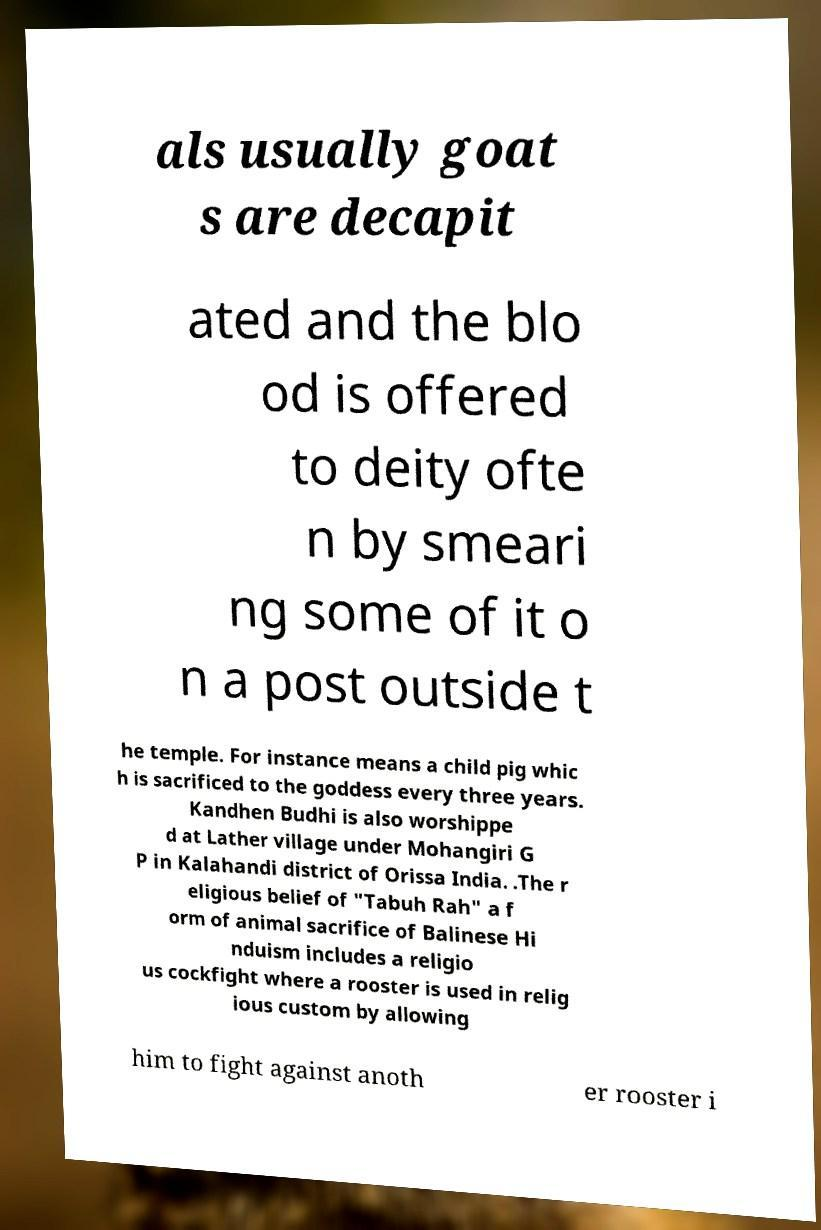Can you read and provide the text displayed in the image?This photo seems to have some interesting text. Can you extract and type it out for me? als usually goat s are decapit ated and the blo od is offered to deity ofte n by smeari ng some of it o n a post outside t he temple. For instance means a child pig whic h is sacrificed to the goddess every three years. Kandhen Budhi is also worshippe d at Lather village under Mohangiri G P in Kalahandi district of Orissa India. .The r eligious belief of "Tabuh Rah" a f orm of animal sacrifice of Balinese Hi nduism includes a religio us cockfight where a rooster is used in relig ious custom by allowing him to fight against anoth er rooster i 